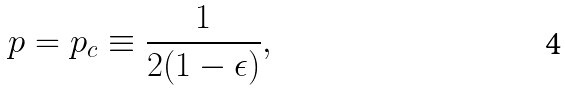<formula> <loc_0><loc_0><loc_500><loc_500>p = p _ { c } \equiv \frac { 1 } { 2 ( 1 - \epsilon ) } ,</formula> 